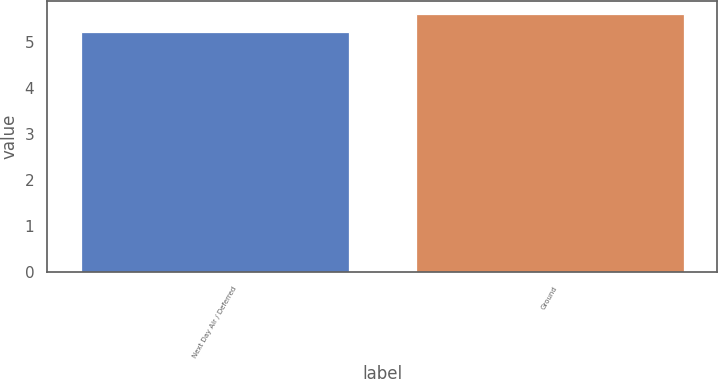Convert chart to OTSL. <chart><loc_0><loc_0><loc_500><loc_500><bar_chart><fcel>Next Day Air / Deferred<fcel>Ground<nl><fcel>5.2<fcel>5.6<nl></chart> 